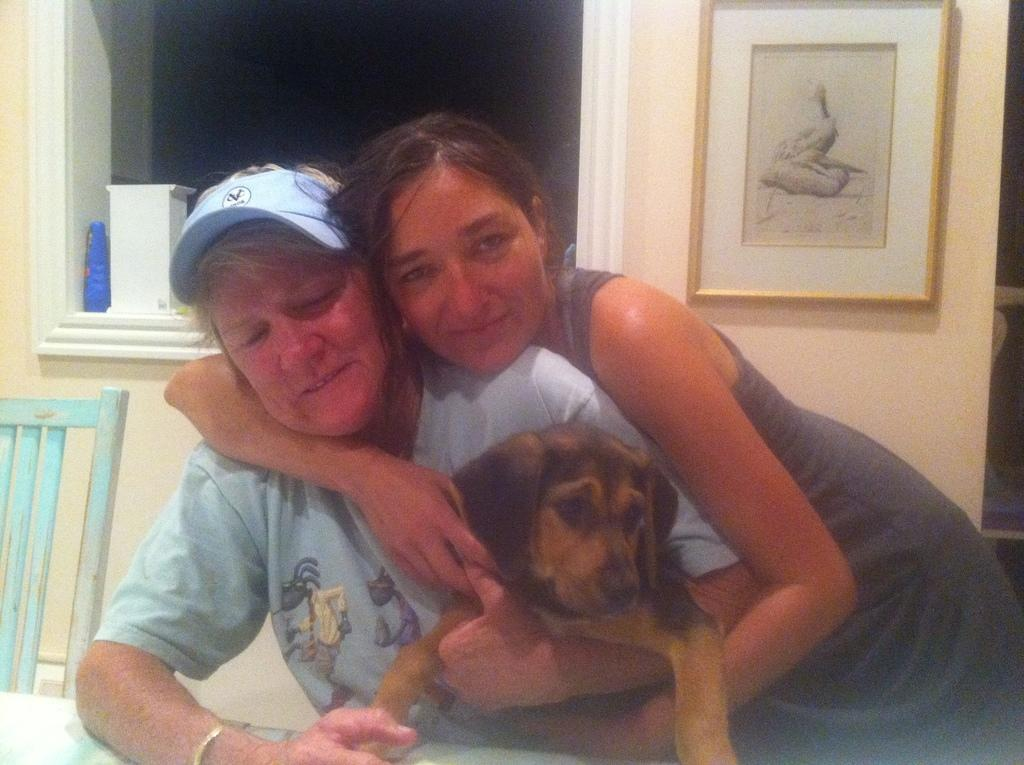How many people are in the image? There are two people in the image. What are the two people doing in the image? The two people are holding a dog. What are the two people sitting on in the image? The two people are sitting on a chair. What type of owl can be seen sitting on the cent in the image? There is no owl or cent present in the image. How many stars are visible in the image? There are no stars visible in the image. 